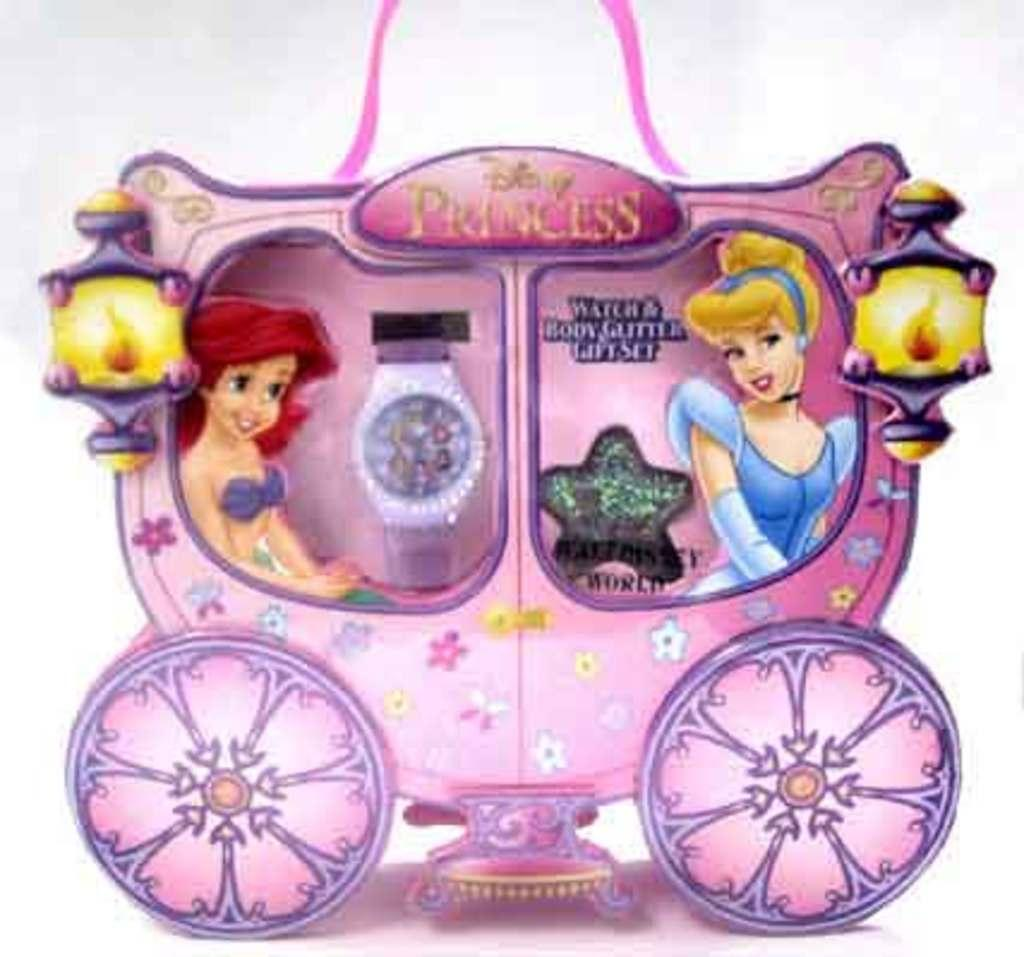What is the main subject in the center of the image? There is a vehicle in the center of the image. Who or what is inside the vehicle? There is a mermaid and a Barbie in the vehicle. Can you identify any accessories or items in the image? There is a watch visible in the image. What can be seen that provides illumination in the image? There are lights in the image. How often does the mermaid wash the vehicle in the image? There is no indication in the image that the mermaid is washing the vehicle, nor is there any information about the frequency of such an activity. 